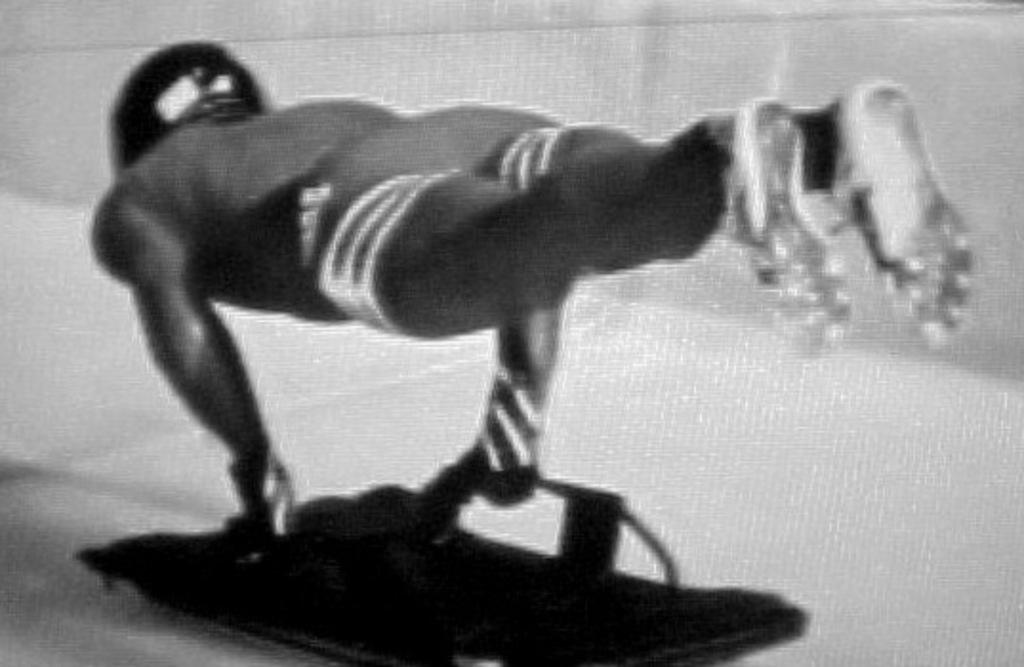What is the main subject of the image? There is a person in the image. What is the person doing in the image? The person appears to be doing an exercise. What is the color scheme of the image? The image is in black and white color. What invention can be seen in the background of the image? There is no invention visible in the image; it only features a person exercising in black and white. 